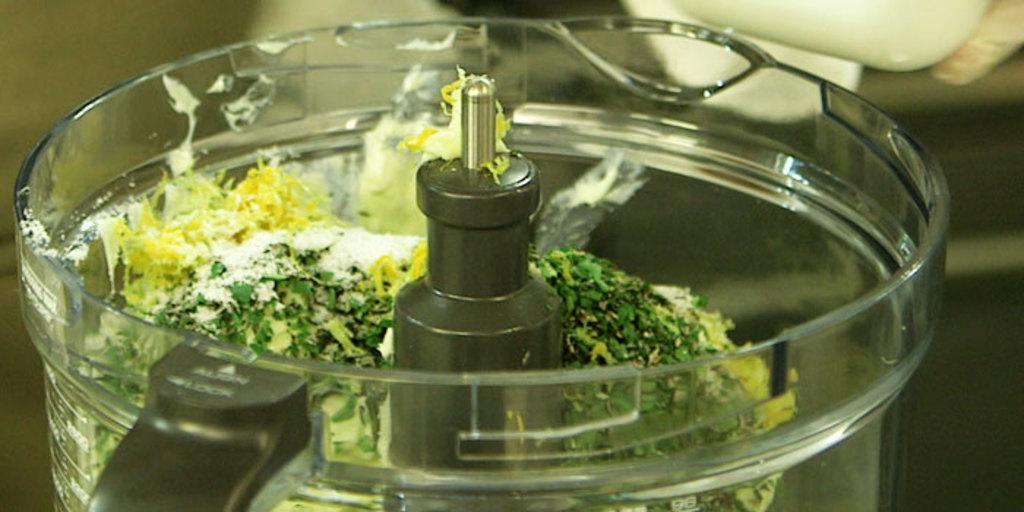What is the focus of the image? The image is a zoomed-in view. What can be seen in the foreground of the image? There is a container in the foreground of the image. What is the purpose of the container in the image? The container holds food items. What else can be seen in the image besides the container? There are other items visible in the background of the image. How is the glue being used in the image? There is no glue present in the image. What type of fight is taking place in the background of the image? There is no fight present in the image; it is a still image of a container and other items. 